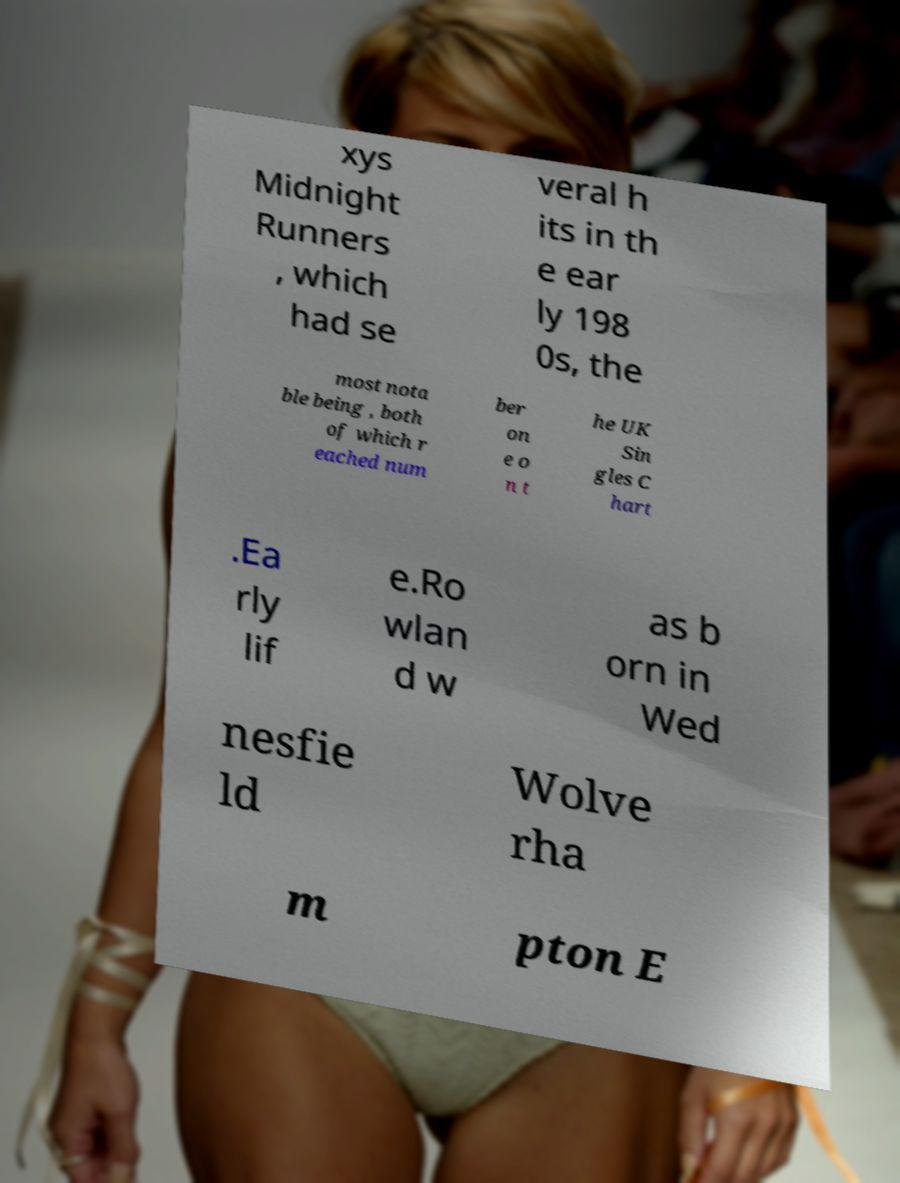Could you assist in decoding the text presented in this image and type it out clearly? xys Midnight Runners , which had se veral h its in th e ear ly 198 0s, the most nota ble being , both of which r eached num ber on e o n t he UK Sin gles C hart .Ea rly lif e.Ro wlan d w as b orn in Wed nesfie ld Wolve rha m pton E 